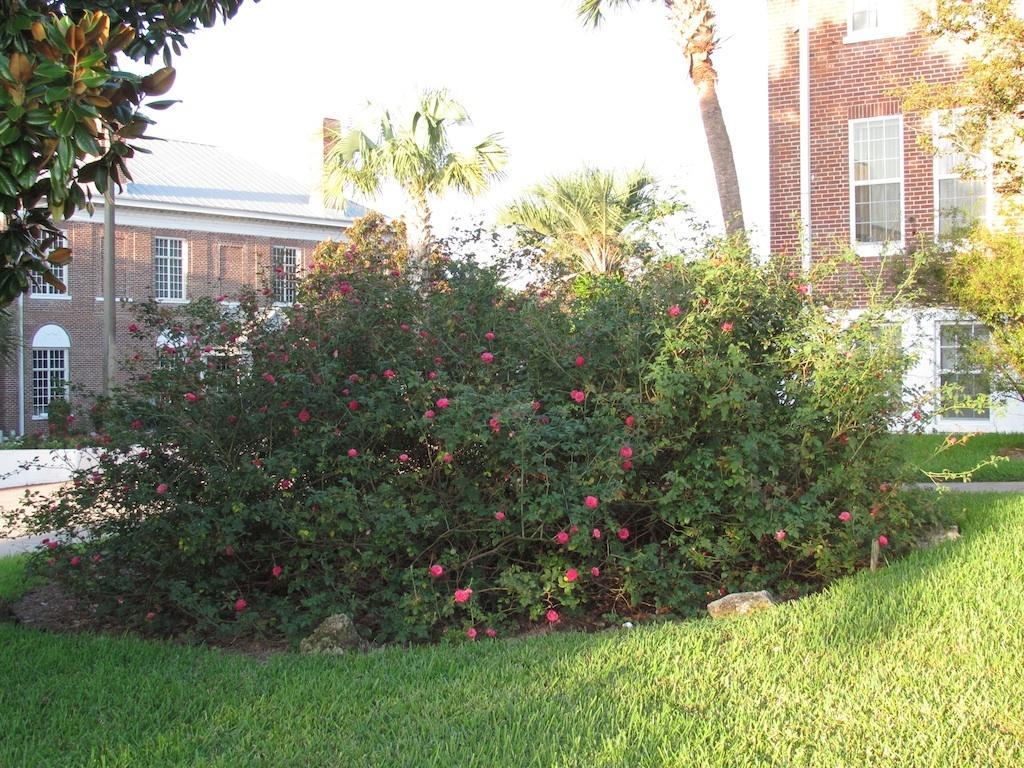Could you give a brief overview of what you see in this image? In this image there are buildings. In front of the buildings there are plants. There are flowers to the plants. At the bottom there is grass on the ground. There are trees in the image. At the top there is the sky. 